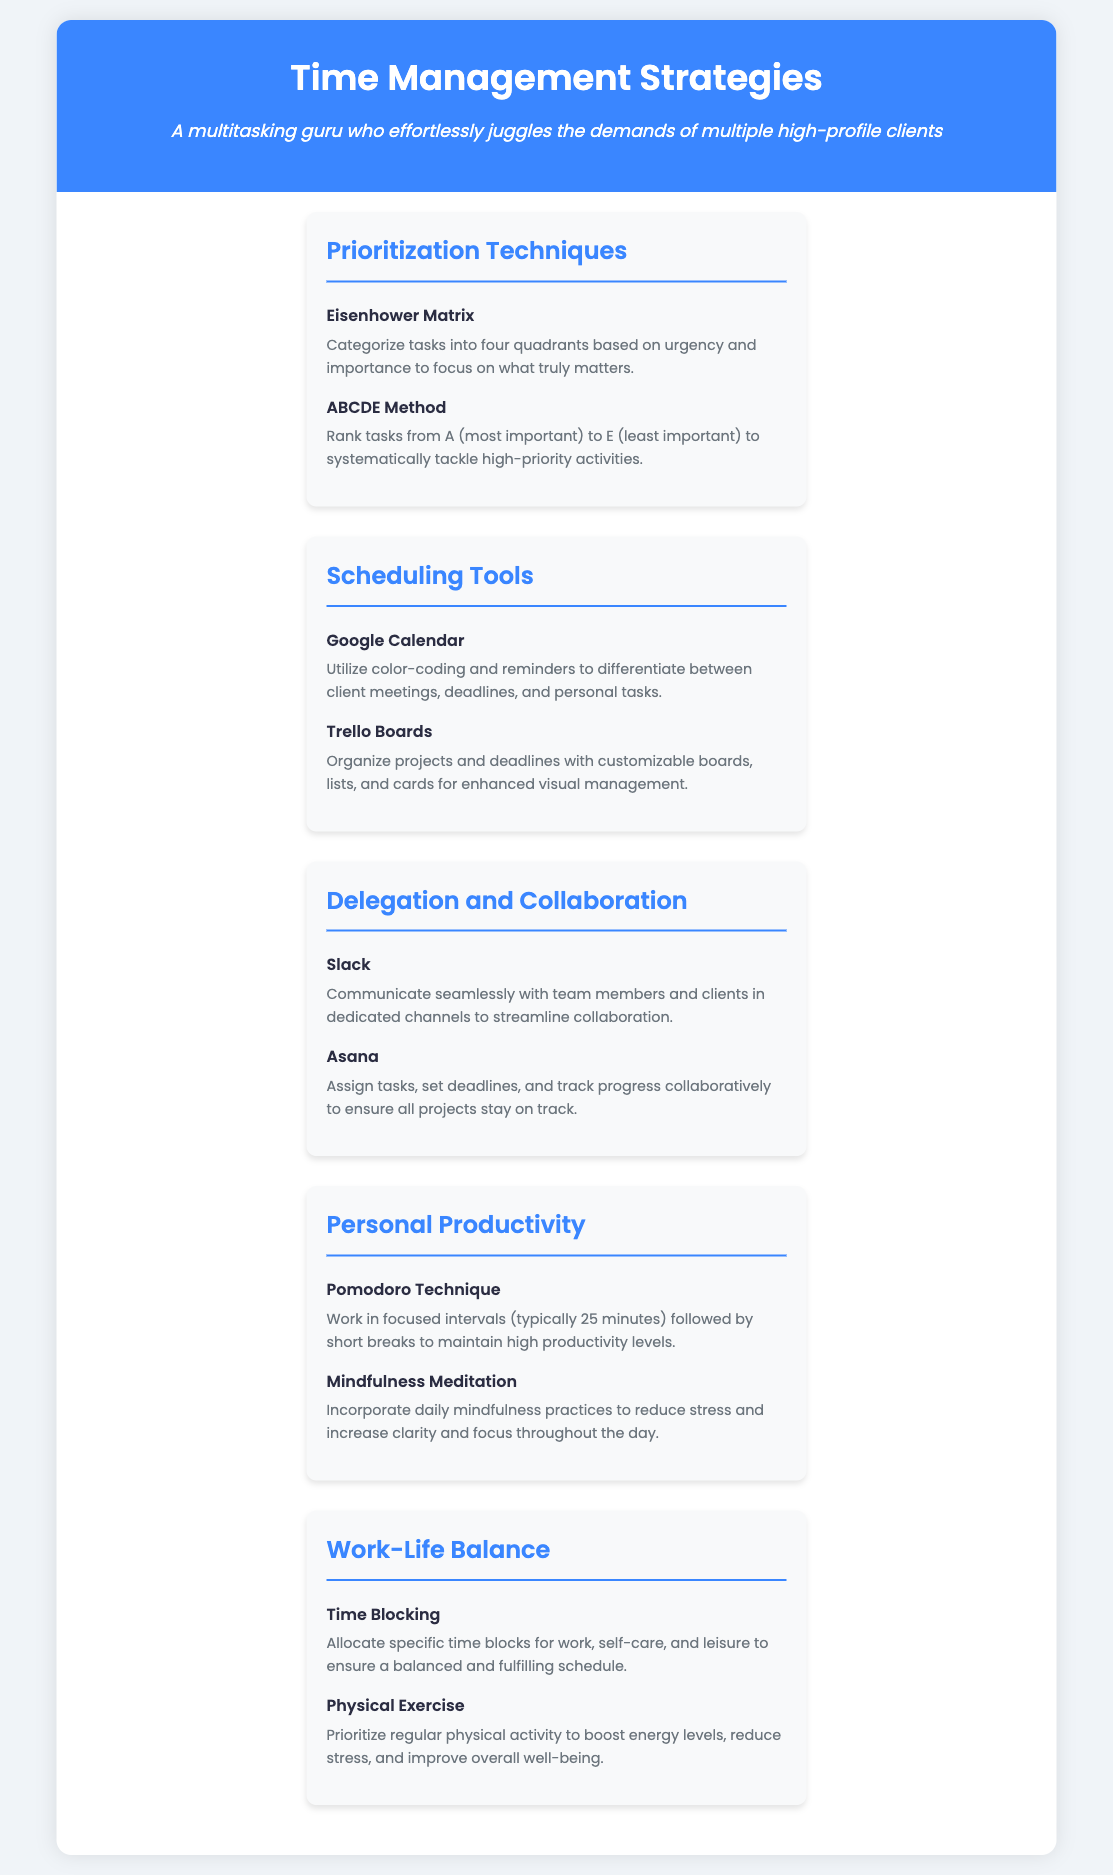what is the title of the document? The title is prominently displayed in the header section of the document.
Answer: Time Management Strategies how many prioritization techniques are listed? The document lists two specific prioritization techniques under the respective section.
Answer: 2 what scheduling tool uses color-coding? The document mentions a specific scheduling tool that utilizes color-coding and reminders for organization.
Answer: Google Calendar which method helps in breaking work into intervals? A personal productivity technique is described that involves focused work periods followed by breaks.
Answer: Pomodoro Technique what is a strategy for achieving work-life balance mentioned? The document outlines specific strategies aimed at promoting work-life balance.
Answer: Time Blocking how many tools are recommended for delegation and collaboration? The document suggests two distinct tools available for collaboration and task delegation purposes.
Answer: 2 what type of meditation is included for personal productivity? A mindfulness practice specifically aimed at reducing stress and increasing focus is included in the productivity section.
Answer: Mindfulness Meditation what is recommended for enhancing overall well-being? The document emphasizes the importance of a specific activity to boost energy levels and reduce stress.
Answer: Physical Exercise 